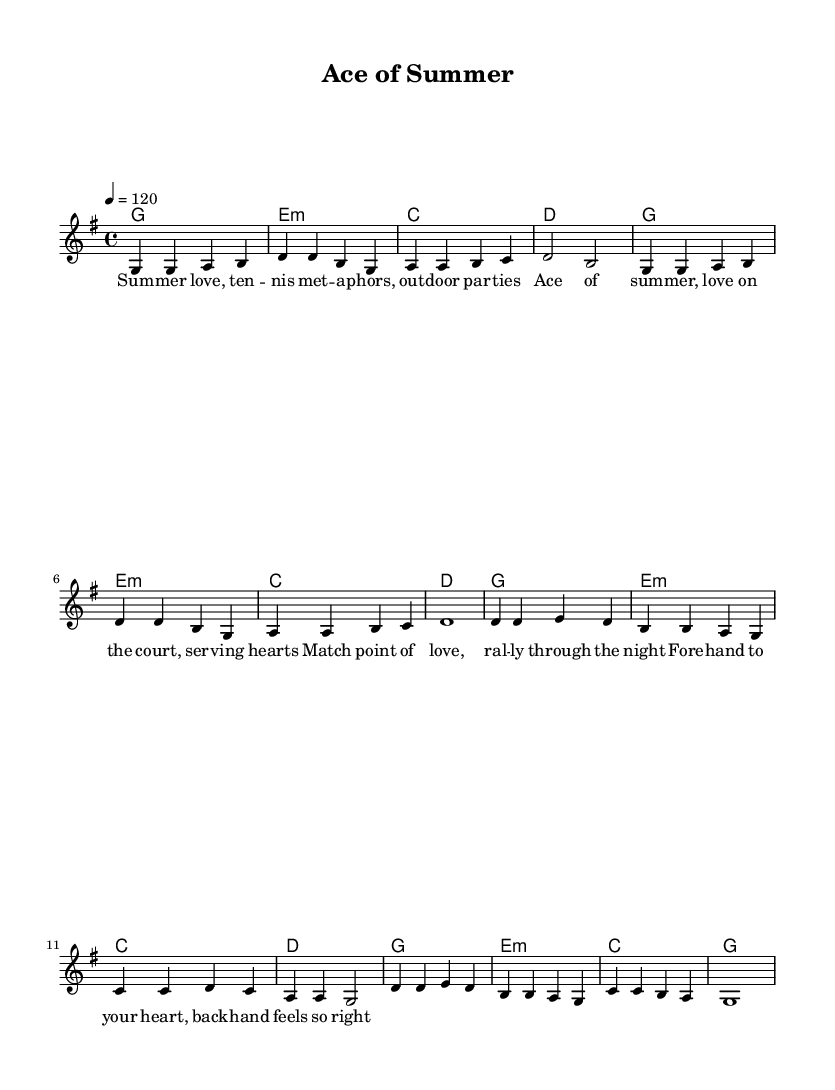What is the key signature of this music? The key signature is G major, which has one sharp (F#). This can be inferred from the key indicated at the beginning of the score.
Answer: G major What is the time signature of this music? The time signature is 4/4, which indicates that there are four beats in each measure. This is shown at the beginning of the score.
Answer: 4/4 What is the tempo marking of the music? The tempo marking is 120 beats per minute, indicated in the tempo section with "4 = 120". This means each quarter note should be played at a speed of 120 beats in one minute.
Answer: 120 How many measures are there in the chorus section? The chorus section consists of four measures, as indicated by the grouping of the notes and the lyric structure in the score.
Answer: 4 Which K-Pop theme does this music evoke? The music evokes a summer theme, as indicated by the title "Ace of Summer" and the lyrics that mention summer, love, and outdoor parties. This aligns with common K-Pop elements focused on seasonal celebrations.
Answer: Summer What is the first note of the melody? The first note of the melody is G, as it is the initial note shown in the melody line of the score.
Answer: G 